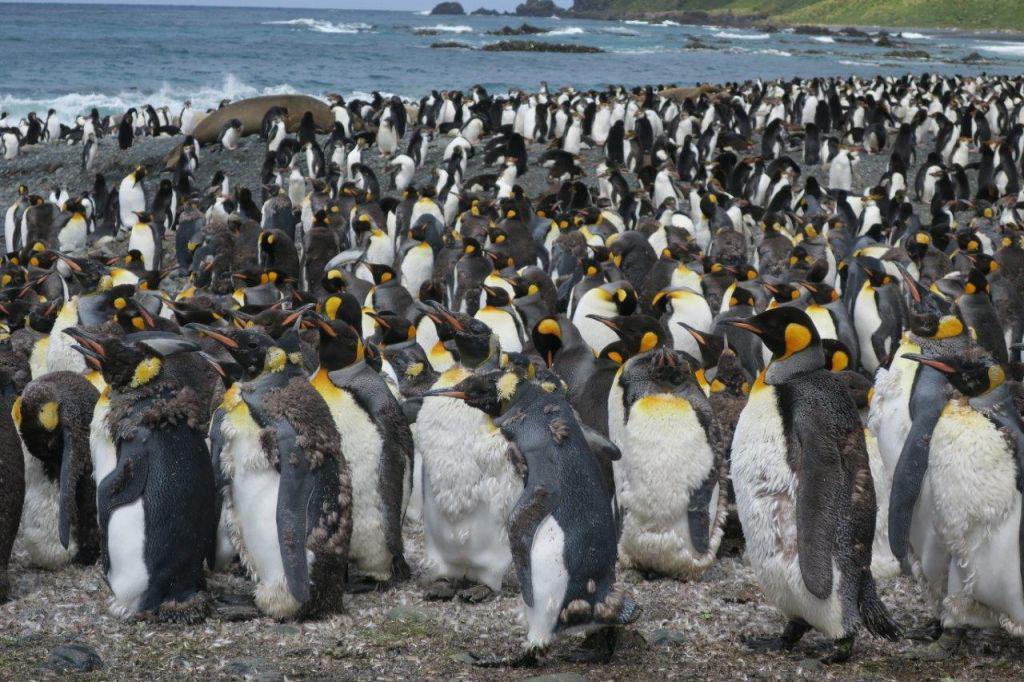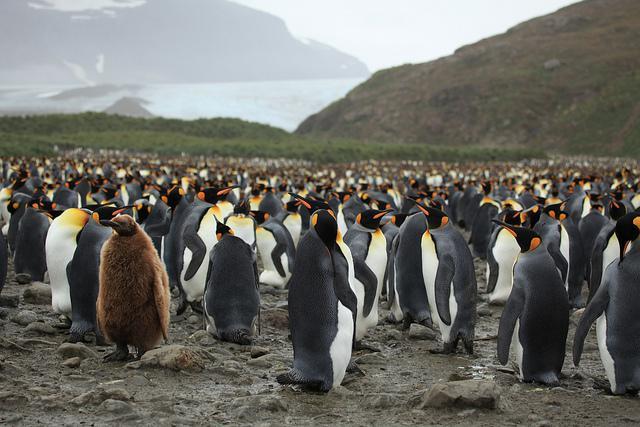The first image is the image on the left, the second image is the image on the right. Assess this claim about the two images: "A brown-feathered penguin is standing at the front of a mass of penguins.". Correct or not? Answer yes or no. Yes. The first image is the image on the left, the second image is the image on the right. Examine the images to the left and right. Is the description "The ocean shore is seen behind the penguins" accurate? Answer yes or no. Yes. 